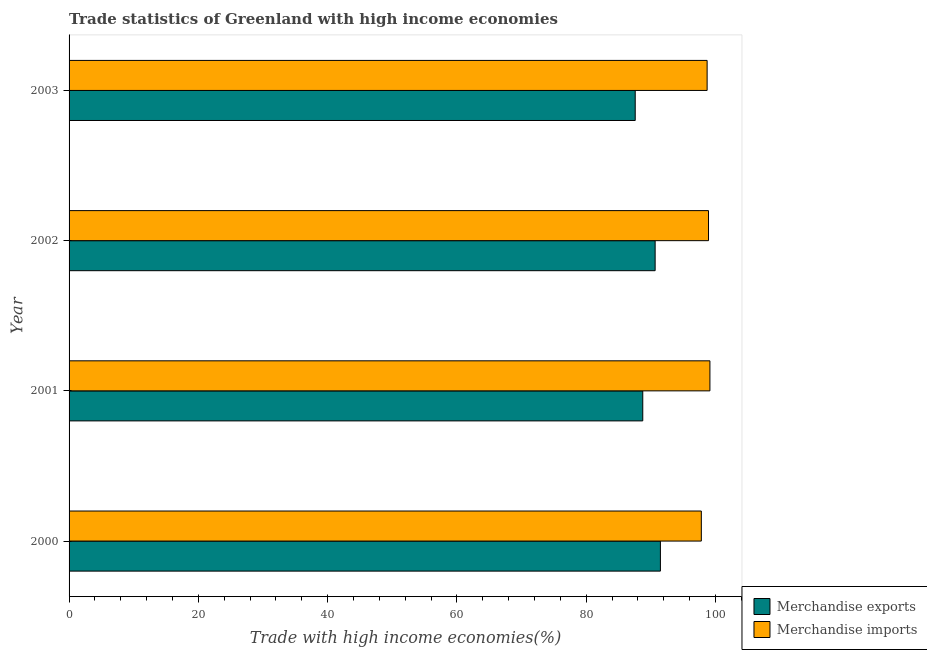How many bars are there on the 3rd tick from the top?
Your answer should be very brief. 2. In how many cases, is the number of bars for a given year not equal to the number of legend labels?
Offer a terse response. 0. What is the merchandise exports in 2001?
Make the answer very short. 88.75. Across all years, what is the maximum merchandise imports?
Make the answer very short. 99.13. Across all years, what is the minimum merchandise exports?
Make the answer very short. 87.58. What is the total merchandise imports in the graph?
Make the answer very short. 394.55. What is the difference between the merchandise exports in 2000 and that in 2001?
Offer a very short reply. 2.73. What is the difference between the merchandise imports in 2002 and the merchandise exports in 2001?
Ensure brevity in your answer.  10.17. What is the average merchandise exports per year?
Your answer should be compact. 89.61. In the year 2002, what is the difference between the merchandise imports and merchandise exports?
Your response must be concise. 8.26. In how many years, is the merchandise exports greater than 12 %?
Offer a very short reply. 4. What is the ratio of the merchandise exports in 2002 to that in 2003?
Ensure brevity in your answer.  1.03. Is the difference between the merchandise imports in 2000 and 2001 greater than the difference between the merchandise exports in 2000 and 2001?
Your response must be concise. No. What is the difference between the highest and the second highest merchandise imports?
Your answer should be very brief. 0.22. What is the difference between the highest and the lowest merchandise exports?
Your response must be concise. 3.89. In how many years, is the merchandise exports greater than the average merchandise exports taken over all years?
Your response must be concise. 2. Are all the bars in the graph horizontal?
Your answer should be very brief. Yes. How many years are there in the graph?
Make the answer very short. 4. Are the values on the major ticks of X-axis written in scientific E-notation?
Your answer should be compact. No. Does the graph contain any zero values?
Give a very brief answer. No. How many legend labels are there?
Provide a short and direct response. 2. What is the title of the graph?
Keep it short and to the point. Trade statistics of Greenland with high income economies. Does "Diarrhea" appear as one of the legend labels in the graph?
Offer a terse response. No. What is the label or title of the X-axis?
Your answer should be very brief. Trade with high income economies(%). What is the label or title of the Y-axis?
Offer a very short reply. Year. What is the Trade with high income economies(%) in Merchandise exports in 2000?
Make the answer very short. 91.47. What is the Trade with high income economies(%) in Merchandise imports in 2000?
Offer a terse response. 97.8. What is the Trade with high income economies(%) of Merchandise exports in 2001?
Ensure brevity in your answer.  88.75. What is the Trade with high income economies(%) in Merchandise imports in 2001?
Provide a short and direct response. 99.13. What is the Trade with high income economies(%) in Merchandise exports in 2002?
Give a very brief answer. 90.66. What is the Trade with high income economies(%) of Merchandise imports in 2002?
Your answer should be very brief. 98.92. What is the Trade with high income economies(%) of Merchandise exports in 2003?
Offer a terse response. 87.58. What is the Trade with high income economies(%) in Merchandise imports in 2003?
Give a very brief answer. 98.7. Across all years, what is the maximum Trade with high income economies(%) of Merchandise exports?
Provide a succinct answer. 91.47. Across all years, what is the maximum Trade with high income economies(%) of Merchandise imports?
Give a very brief answer. 99.13. Across all years, what is the minimum Trade with high income economies(%) in Merchandise exports?
Provide a succinct answer. 87.58. Across all years, what is the minimum Trade with high income economies(%) of Merchandise imports?
Offer a very short reply. 97.8. What is the total Trade with high income economies(%) in Merchandise exports in the graph?
Offer a very short reply. 358.45. What is the total Trade with high income economies(%) of Merchandise imports in the graph?
Give a very brief answer. 394.55. What is the difference between the Trade with high income economies(%) of Merchandise exports in 2000 and that in 2001?
Offer a very short reply. 2.73. What is the difference between the Trade with high income economies(%) in Merchandise imports in 2000 and that in 2001?
Your answer should be compact. -1.33. What is the difference between the Trade with high income economies(%) of Merchandise exports in 2000 and that in 2002?
Your answer should be compact. 0.82. What is the difference between the Trade with high income economies(%) in Merchandise imports in 2000 and that in 2002?
Provide a short and direct response. -1.11. What is the difference between the Trade with high income economies(%) in Merchandise exports in 2000 and that in 2003?
Provide a short and direct response. 3.89. What is the difference between the Trade with high income economies(%) in Merchandise imports in 2000 and that in 2003?
Give a very brief answer. -0.9. What is the difference between the Trade with high income economies(%) in Merchandise exports in 2001 and that in 2002?
Offer a terse response. -1.91. What is the difference between the Trade with high income economies(%) in Merchandise imports in 2001 and that in 2002?
Offer a very short reply. 0.22. What is the difference between the Trade with high income economies(%) in Merchandise imports in 2001 and that in 2003?
Give a very brief answer. 0.43. What is the difference between the Trade with high income economies(%) in Merchandise exports in 2002 and that in 2003?
Ensure brevity in your answer.  3.08. What is the difference between the Trade with high income economies(%) of Merchandise imports in 2002 and that in 2003?
Your answer should be very brief. 0.22. What is the difference between the Trade with high income economies(%) in Merchandise exports in 2000 and the Trade with high income economies(%) in Merchandise imports in 2001?
Your response must be concise. -7.66. What is the difference between the Trade with high income economies(%) in Merchandise exports in 2000 and the Trade with high income economies(%) in Merchandise imports in 2002?
Offer a very short reply. -7.44. What is the difference between the Trade with high income economies(%) of Merchandise exports in 2000 and the Trade with high income economies(%) of Merchandise imports in 2003?
Your response must be concise. -7.23. What is the difference between the Trade with high income economies(%) in Merchandise exports in 2001 and the Trade with high income economies(%) in Merchandise imports in 2002?
Offer a terse response. -10.17. What is the difference between the Trade with high income economies(%) in Merchandise exports in 2001 and the Trade with high income economies(%) in Merchandise imports in 2003?
Keep it short and to the point. -9.95. What is the difference between the Trade with high income economies(%) in Merchandise exports in 2002 and the Trade with high income economies(%) in Merchandise imports in 2003?
Provide a short and direct response. -8.04. What is the average Trade with high income economies(%) in Merchandise exports per year?
Make the answer very short. 89.61. What is the average Trade with high income economies(%) of Merchandise imports per year?
Offer a terse response. 98.64. In the year 2000, what is the difference between the Trade with high income economies(%) of Merchandise exports and Trade with high income economies(%) of Merchandise imports?
Offer a terse response. -6.33. In the year 2001, what is the difference between the Trade with high income economies(%) of Merchandise exports and Trade with high income economies(%) of Merchandise imports?
Your answer should be compact. -10.39. In the year 2002, what is the difference between the Trade with high income economies(%) of Merchandise exports and Trade with high income economies(%) of Merchandise imports?
Provide a short and direct response. -8.26. In the year 2003, what is the difference between the Trade with high income economies(%) of Merchandise exports and Trade with high income economies(%) of Merchandise imports?
Your answer should be very brief. -11.12. What is the ratio of the Trade with high income economies(%) of Merchandise exports in 2000 to that in 2001?
Make the answer very short. 1.03. What is the ratio of the Trade with high income economies(%) in Merchandise imports in 2000 to that in 2001?
Give a very brief answer. 0.99. What is the ratio of the Trade with high income economies(%) of Merchandise exports in 2000 to that in 2002?
Provide a succinct answer. 1.01. What is the ratio of the Trade with high income economies(%) in Merchandise imports in 2000 to that in 2002?
Give a very brief answer. 0.99. What is the ratio of the Trade with high income economies(%) of Merchandise exports in 2000 to that in 2003?
Keep it short and to the point. 1.04. What is the ratio of the Trade with high income economies(%) of Merchandise imports in 2000 to that in 2003?
Offer a terse response. 0.99. What is the ratio of the Trade with high income economies(%) in Merchandise exports in 2001 to that in 2002?
Ensure brevity in your answer.  0.98. What is the ratio of the Trade with high income economies(%) of Merchandise exports in 2001 to that in 2003?
Keep it short and to the point. 1.01. What is the ratio of the Trade with high income economies(%) in Merchandise imports in 2001 to that in 2003?
Your response must be concise. 1. What is the ratio of the Trade with high income economies(%) of Merchandise exports in 2002 to that in 2003?
Offer a terse response. 1.04. What is the ratio of the Trade with high income economies(%) of Merchandise imports in 2002 to that in 2003?
Your answer should be very brief. 1. What is the difference between the highest and the second highest Trade with high income economies(%) in Merchandise exports?
Offer a very short reply. 0.82. What is the difference between the highest and the second highest Trade with high income economies(%) of Merchandise imports?
Your response must be concise. 0.22. What is the difference between the highest and the lowest Trade with high income economies(%) of Merchandise exports?
Keep it short and to the point. 3.89. What is the difference between the highest and the lowest Trade with high income economies(%) of Merchandise imports?
Make the answer very short. 1.33. 